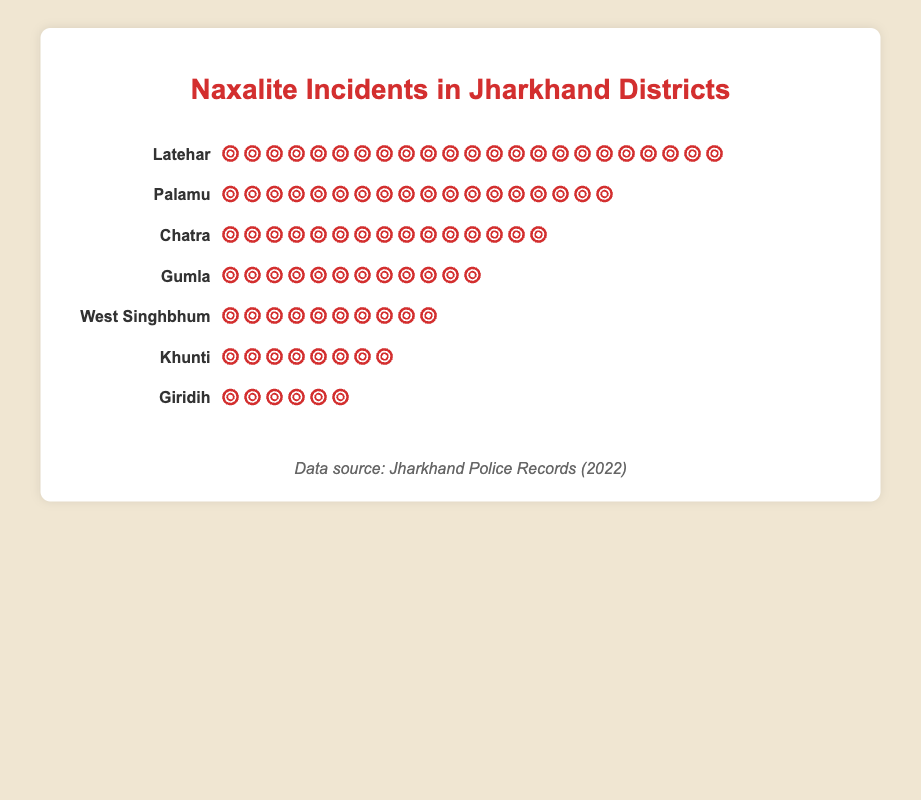Which district has the highest number of Naxalite incidents? By referring to the figure, we see that Latehar has the most icons, with 23 explosions indicated.
Answer: Latehar Which district has the fewest number of Naxalite incidents? According to the figure, Giridih has the least number of incidents, represented by 6 explosion icons.
Answer: Giridih What's the total number of Naxalite incidents across all the listed districts? By summing the number of incidents from all districts: 23 (Latehar) + 18 (Palamu) + 15 (Chatra) + 12 (Gumla) + 10 (West Singhbhum) + 8 (Khunti) + 6 (Giridih) = 92.
Answer: 92 Which districts have more than 10 Naxalite incidents? From the figure, the districts with more than 10 incidents are Latehar (23), Palamu (18), Chatra (15), and Gumla (12).
Answer: Latehar, Palamu, Chatra, Gumla How many districts have fewer than 10 Naxalite incidents? The districts with fewer than 10 incidents are West Singhbhum (10), Khunti (8), and Giridih (6). Counting these districts, we get 3.
Answer: 3 What's the difference in the number of Naxalite incidents between Latehar and Chatra? According to the chart, Latehar has 23 incidents and Chatra has 15. Subtracting these: 23 - 15 = 8.
Answer: 8 What's the average number of Naxalite incidents across the 7 listed districts? To find the average, sum up the total incidents (92) and divide by the number of districts (7): 92 / 7 ≈ 13.14.
Answer: 13.14 Which district appears to be the fourth most affected by Naxalite incidents? By visually checking the count of explosion icons, Gumla, with 12 incidents, appears as the fourth most affected district.
Answer: Gumla How many more incidents does Palamu have compared to Khunti? Palamu has 18 incidents, and Khunti has 8. The difference is 18 - 8 = 10.
Answer: 10 What's the sum of Naxalite incidents in Khunti and Giridih? Adding the incidents in Khunti (8) and Giridih (6) gives 8 + 6 = 14.
Answer: 14 